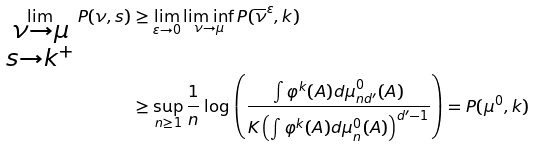Convert formula to latex. <formula><loc_0><loc_0><loc_500><loc_500>\lim _ { \substack { \nu \to \mu \\ s \to k ^ { + } } } P ( \nu , s ) & \geq \lim _ { \varepsilon \to 0 } \liminf _ { \nu \to \mu } P ( \overline { \nu } ^ { \varepsilon } , k ) \\ & \geq \sup _ { n \geq 1 } \frac { 1 } { n } \log \left ( \frac { \int \varphi ^ { k } ( A ) d \mu _ { n d ^ { \prime } } ^ { 0 } ( A ) } { K \left ( \int \varphi ^ { k } ( A ) d \mu _ { n } ^ { 0 } ( A ) \right ) ^ { d ^ { \prime } - 1 } } \right ) = P ( \mu ^ { 0 } , k )</formula> 